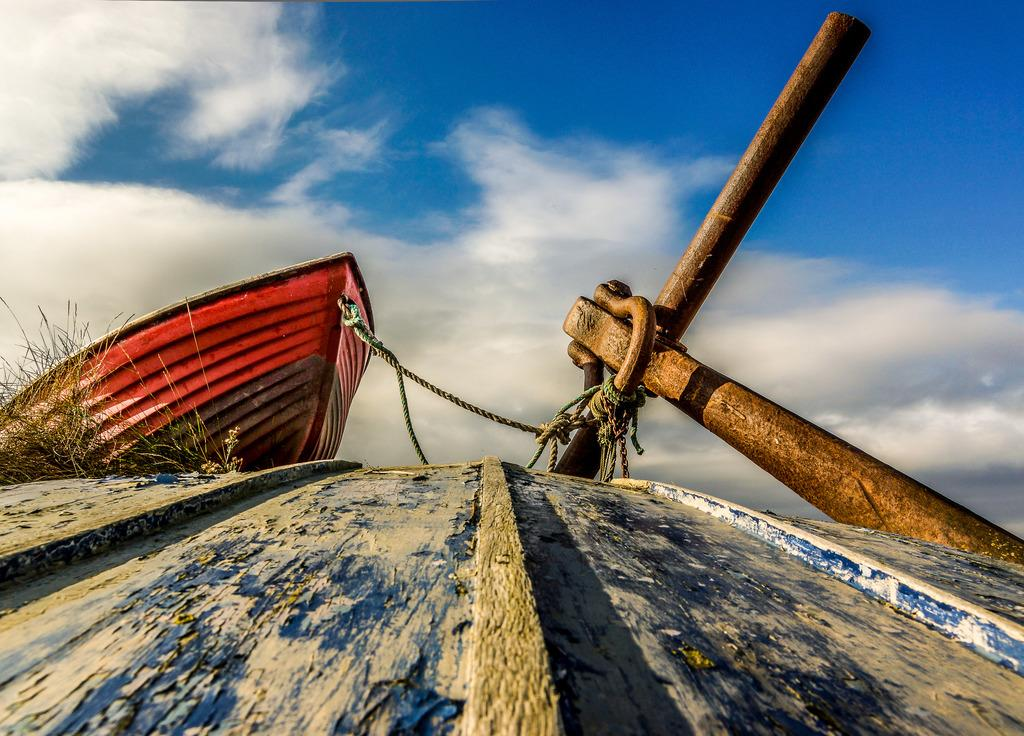What type of surface is visible in the image? There is a wooden surface in the image. What can be seen in the background of the image? There are plants and a boat in the background of the image. How is the boat secured in the image? The boat is tied to an iron rod. What is visible above the wooden surface and the boat? The sky is visible in the image. Where are the scissors used for cutting the dinosaurs in the image? There are no scissors or dinosaurs present in the image. 